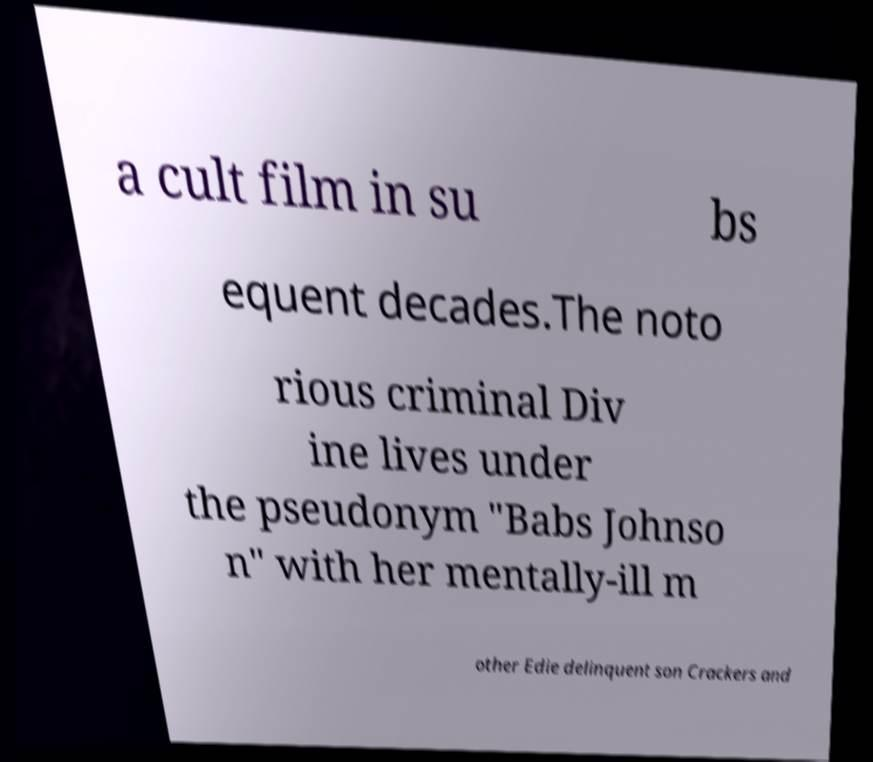Can you accurately transcribe the text from the provided image for me? a cult film in su bs equent decades.The noto rious criminal Div ine lives under the pseudonym "Babs Johnso n" with her mentally-ill m other Edie delinquent son Crackers and 